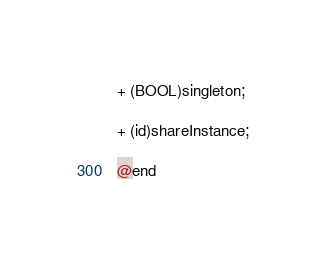<code> <loc_0><loc_0><loc_500><loc_500><_C_>+ (BOOL)singleton;

+ (id)shareInstance;

@end
</code> 